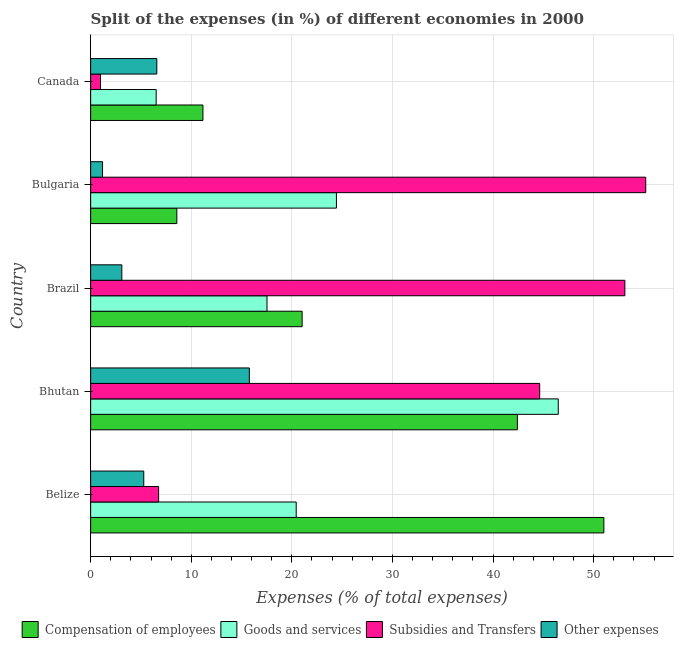How many different coloured bars are there?
Offer a very short reply. 4. Are the number of bars on each tick of the Y-axis equal?
Your response must be concise. Yes. How many bars are there on the 2nd tick from the bottom?
Provide a short and direct response. 4. What is the label of the 2nd group of bars from the top?
Your response must be concise. Bulgaria. What is the percentage of amount spent on subsidies in Canada?
Keep it short and to the point. 0.98. Across all countries, what is the maximum percentage of amount spent on other expenses?
Your response must be concise. 15.77. Across all countries, what is the minimum percentage of amount spent on subsidies?
Offer a very short reply. 0.98. In which country was the percentage of amount spent on compensation of employees maximum?
Your answer should be compact. Belize. In which country was the percentage of amount spent on compensation of employees minimum?
Your answer should be compact. Bulgaria. What is the total percentage of amount spent on compensation of employees in the graph?
Keep it short and to the point. 134.18. What is the difference between the percentage of amount spent on other expenses in Belize and that in Canada?
Give a very brief answer. -1.3. What is the difference between the percentage of amount spent on compensation of employees in Bhutan and the percentage of amount spent on other expenses in Canada?
Your response must be concise. 35.84. What is the average percentage of amount spent on compensation of employees per country?
Offer a very short reply. 26.84. What is the difference between the percentage of amount spent on other expenses and percentage of amount spent on goods and services in Bhutan?
Your response must be concise. -30.71. In how many countries, is the percentage of amount spent on other expenses greater than 14 %?
Ensure brevity in your answer.  1. What is the ratio of the percentage of amount spent on goods and services in Bhutan to that in Brazil?
Provide a short and direct response. 2.65. Is the percentage of amount spent on compensation of employees in Belize less than that in Canada?
Your answer should be very brief. No. What is the difference between the highest and the second highest percentage of amount spent on other expenses?
Your answer should be very brief. 9.2. What is the difference between the highest and the lowest percentage of amount spent on goods and services?
Provide a succinct answer. 39.97. In how many countries, is the percentage of amount spent on subsidies greater than the average percentage of amount spent on subsidies taken over all countries?
Offer a very short reply. 3. What does the 1st bar from the top in Bhutan represents?
Give a very brief answer. Other expenses. What does the 4th bar from the bottom in Bulgaria represents?
Your response must be concise. Other expenses. How many bars are there?
Offer a very short reply. 20. How many countries are there in the graph?
Make the answer very short. 5. What is the difference between two consecutive major ticks on the X-axis?
Your response must be concise. 10. Are the values on the major ticks of X-axis written in scientific E-notation?
Your response must be concise. No. Where does the legend appear in the graph?
Your response must be concise. Bottom center. What is the title of the graph?
Keep it short and to the point. Split of the expenses (in %) of different economies in 2000. Does "HFC gas" appear as one of the legend labels in the graph?
Make the answer very short. No. What is the label or title of the X-axis?
Offer a terse response. Expenses (% of total expenses). What is the Expenses (% of total expenses) in Compensation of employees in Belize?
Offer a very short reply. 51.01. What is the Expenses (% of total expenses) in Goods and services in Belize?
Your answer should be compact. 20.43. What is the Expenses (% of total expenses) of Subsidies and Transfers in Belize?
Give a very brief answer. 6.76. What is the Expenses (% of total expenses) in Other expenses in Belize?
Offer a very short reply. 5.28. What is the Expenses (% of total expenses) of Compensation of employees in Bhutan?
Your answer should be very brief. 42.42. What is the Expenses (% of total expenses) in Goods and services in Bhutan?
Make the answer very short. 46.48. What is the Expenses (% of total expenses) of Subsidies and Transfers in Bhutan?
Your answer should be very brief. 44.63. What is the Expenses (% of total expenses) of Other expenses in Bhutan?
Ensure brevity in your answer.  15.77. What is the Expenses (% of total expenses) in Compensation of employees in Brazil?
Your answer should be compact. 21.02. What is the Expenses (% of total expenses) of Goods and services in Brazil?
Provide a short and direct response. 17.53. What is the Expenses (% of total expenses) in Subsidies and Transfers in Brazil?
Your response must be concise. 53.1. What is the Expenses (% of total expenses) in Other expenses in Brazil?
Your response must be concise. 3.1. What is the Expenses (% of total expenses) in Compensation of employees in Bulgaria?
Keep it short and to the point. 8.57. What is the Expenses (% of total expenses) in Goods and services in Bulgaria?
Provide a short and direct response. 24.43. What is the Expenses (% of total expenses) of Subsidies and Transfers in Bulgaria?
Provide a short and direct response. 55.18. What is the Expenses (% of total expenses) in Other expenses in Bulgaria?
Keep it short and to the point. 1.18. What is the Expenses (% of total expenses) of Compensation of employees in Canada?
Make the answer very short. 11.16. What is the Expenses (% of total expenses) of Goods and services in Canada?
Give a very brief answer. 6.51. What is the Expenses (% of total expenses) of Subsidies and Transfers in Canada?
Your response must be concise. 0.98. What is the Expenses (% of total expenses) in Other expenses in Canada?
Offer a terse response. 6.58. Across all countries, what is the maximum Expenses (% of total expenses) in Compensation of employees?
Provide a short and direct response. 51.01. Across all countries, what is the maximum Expenses (% of total expenses) in Goods and services?
Ensure brevity in your answer.  46.48. Across all countries, what is the maximum Expenses (% of total expenses) of Subsidies and Transfers?
Your answer should be compact. 55.18. Across all countries, what is the maximum Expenses (% of total expenses) in Other expenses?
Offer a terse response. 15.77. Across all countries, what is the minimum Expenses (% of total expenses) in Compensation of employees?
Provide a short and direct response. 8.57. Across all countries, what is the minimum Expenses (% of total expenses) in Goods and services?
Offer a terse response. 6.51. Across all countries, what is the minimum Expenses (% of total expenses) of Subsidies and Transfers?
Offer a terse response. 0.98. Across all countries, what is the minimum Expenses (% of total expenses) in Other expenses?
Offer a terse response. 1.18. What is the total Expenses (% of total expenses) of Compensation of employees in the graph?
Offer a very short reply. 134.18. What is the total Expenses (% of total expenses) in Goods and services in the graph?
Your answer should be very brief. 115.38. What is the total Expenses (% of total expenses) of Subsidies and Transfers in the graph?
Make the answer very short. 160.65. What is the total Expenses (% of total expenses) of Other expenses in the graph?
Provide a short and direct response. 31.91. What is the difference between the Expenses (% of total expenses) in Compensation of employees in Belize and that in Bhutan?
Offer a terse response. 8.6. What is the difference between the Expenses (% of total expenses) in Goods and services in Belize and that in Bhutan?
Ensure brevity in your answer.  -26.05. What is the difference between the Expenses (% of total expenses) in Subsidies and Transfers in Belize and that in Bhutan?
Your answer should be compact. -37.88. What is the difference between the Expenses (% of total expenses) in Other expenses in Belize and that in Bhutan?
Make the answer very short. -10.49. What is the difference between the Expenses (% of total expenses) in Compensation of employees in Belize and that in Brazil?
Give a very brief answer. 29.99. What is the difference between the Expenses (% of total expenses) in Goods and services in Belize and that in Brazil?
Make the answer very short. 2.9. What is the difference between the Expenses (% of total expenses) in Subsidies and Transfers in Belize and that in Brazil?
Your answer should be compact. -46.34. What is the difference between the Expenses (% of total expenses) in Other expenses in Belize and that in Brazil?
Your answer should be compact. 2.18. What is the difference between the Expenses (% of total expenses) in Compensation of employees in Belize and that in Bulgaria?
Provide a short and direct response. 42.45. What is the difference between the Expenses (% of total expenses) of Goods and services in Belize and that in Bulgaria?
Your answer should be compact. -4. What is the difference between the Expenses (% of total expenses) of Subsidies and Transfers in Belize and that in Bulgaria?
Offer a terse response. -48.42. What is the difference between the Expenses (% of total expenses) of Other expenses in Belize and that in Bulgaria?
Ensure brevity in your answer.  4.1. What is the difference between the Expenses (% of total expenses) in Compensation of employees in Belize and that in Canada?
Your answer should be very brief. 39.85. What is the difference between the Expenses (% of total expenses) in Goods and services in Belize and that in Canada?
Your answer should be compact. 13.92. What is the difference between the Expenses (% of total expenses) of Subsidies and Transfers in Belize and that in Canada?
Provide a short and direct response. 5.77. What is the difference between the Expenses (% of total expenses) of Other expenses in Belize and that in Canada?
Provide a short and direct response. -1.3. What is the difference between the Expenses (% of total expenses) of Compensation of employees in Bhutan and that in Brazil?
Keep it short and to the point. 21.4. What is the difference between the Expenses (% of total expenses) of Goods and services in Bhutan and that in Brazil?
Ensure brevity in your answer.  28.95. What is the difference between the Expenses (% of total expenses) in Subsidies and Transfers in Bhutan and that in Brazil?
Your answer should be very brief. -8.47. What is the difference between the Expenses (% of total expenses) in Other expenses in Bhutan and that in Brazil?
Keep it short and to the point. 12.67. What is the difference between the Expenses (% of total expenses) of Compensation of employees in Bhutan and that in Bulgaria?
Provide a succinct answer. 33.85. What is the difference between the Expenses (% of total expenses) in Goods and services in Bhutan and that in Bulgaria?
Offer a very short reply. 22.05. What is the difference between the Expenses (% of total expenses) of Subsidies and Transfers in Bhutan and that in Bulgaria?
Provide a succinct answer. -10.54. What is the difference between the Expenses (% of total expenses) of Other expenses in Bhutan and that in Bulgaria?
Offer a terse response. 14.59. What is the difference between the Expenses (% of total expenses) in Compensation of employees in Bhutan and that in Canada?
Give a very brief answer. 31.26. What is the difference between the Expenses (% of total expenses) of Goods and services in Bhutan and that in Canada?
Offer a very short reply. 39.97. What is the difference between the Expenses (% of total expenses) of Subsidies and Transfers in Bhutan and that in Canada?
Make the answer very short. 43.65. What is the difference between the Expenses (% of total expenses) in Other expenses in Bhutan and that in Canada?
Ensure brevity in your answer.  9.2. What is the difference between the Expenses (% of total expenses) of Compensation of employees in Brazil and that in Bulgaria?
Provide a short and direct response. 12.45. What is the difference between the Expenses (% of total expenses) of Goods and services in Brazil and that in Bulgaria?
Offer a terse response. -6.9. What is the difference between the Expenses (% of total expenses) of Subsidies and Transfers in Brazil and that in Bulgaria?
Make the answer very short. -2.08. What is the difference between the Expenses (% of total expenses) of Other expenses in Brazil and that in Bulgaria?
Ensure brevity in your answer.  1.92. What is the difference between the Expenses (% of total expenses) of Compensation of employees in Brazil and that in Canada?
Ensure brevity in your answer.  9.86. What is the difference between the Expenses (% of total expenses) in Goods and services in Brazil and that in Canada?
Provide a short and direct response. 11.02. What is the difference between the Expenses (% of total expenses) of Subsidies and Transfers in Brazil and that in Canada?
Your response must be concise. 52.12. What is the difference between the Expenses (% of total expenses) in Other expenses in Brazil and that in Canada?
Offer a very short reply. -3.48. What is the difference between the Expenses (% of total expenses) in Compensation of employees in Bulgaria and that in Canada?
Offer a very short reply. -2.6. What is the difference between the Expenses (% of total expenses) of Goods and services in Bulgaria and that in Canada?
Provide a succinct answer. 17.92. What is the difference between the Expenses (% of total expenses) in Subsidies and Transfers in Bulgaria and that in Canada?
Give a very brief answer. 54.19. What is the difference between the Expenses (% of total expenses) in Other expenses in Bulgaria and that in Canada?
Your answer should be compact. -5.39. What is the difference between the Expenses (% of total expenses) of Compensation of employees in Belize and the Expenses (% of total expenses) of Goods and services in Bhutan?
Make the answer very short. 4.53. What is the difference between the Expenses (% of total expenses) of Compensation of employees in Belize and the Expenses (% of total expenses) of Subsidies and Transfers in Bhutan?
Your answer should be very brief. 6.38. What is the difference between the Expenses (% of total expenses) of Compensation of employees in Belize and the Expenses (% of total expenses) of Other expenses in Bhutan?
Make the answer very short. 35.24. What is the difference between the Expenses (% of total expenses) in Goods and services in Belize and the Expenses (% of total expenses) in Subsidies and Transfers in Bhutan?
Keep it short and to the point. -24.2. What is the difference between the Expenses (% of total expenses) of Goods and services in Belize and the Expenses (% of total expenses) of Other expenses in Bhutan?
Give a very brief answer. 4.66. What is the difference between the Expenses (% of total expenses) in Subsidies and Transfers in Belize and the Expenses (% of total expenses) in Other expenses in Bhutan?
Keep it short and to the point. -9.02. What is the difference between the Expenses (% of total expenses) of Compensation of employees in Belize and the Expenses (% of total expenses) of Goods and services in Brazil?
Your answer should be compact. 33.48. What is the difference between the Expenses (% of total expenses) of Compensation of employees in Belize and the Expenses (% of total expenses) of Subsidies and Transfers in Brazil?
Keep it short and to the point. -2.09. What is the difference between the Expenses (% of total expenses) in Compensation of employees in Belize and the Expenses (% of total expenses) in Other expenses in Brazil?
Your answer should be very brief. 47.92. What is the difference between the Expenses (% of total expenses) of Goods and services in Belize and the Expenses (% of total expenses) of Subsidies and Transfers in Brazil?
Provide a short and direct response. -32.67. What is the difference between the Expenses (% of total expenses) of Goods and services in Belize and the Expenses (% of total expenses) of Other expenses in Brazil?
Give a very brief answer. 17.33. What is the difference between the Expenses (% of total expenses) in Subsidies and Transfers in Belize and the Expenses (% of total expenses) in Other expenses in Brazil?
Give a very brief answer. 3.66. What is the difference between the Expenses (% of total expenses) in Compensation of employees in Belize and the Expenses (% of total expenses) in Goods and services in Bulgaria?
Your response must be concise. 26.58. What is the difference between the Expenses (% of total expenses) in Compensation of employees in Belize and the Expenses (% of total expenses) in Subsidies and Transfers in Bulgaria?
Your answer should be compact. -4.16. What is the difference between the Expenses (% of total expenses) in Compensation of employees in Belize and the Expenses (% of total expenses) in Other expenses in Bulgaria?
Provide a succinct answer. 49.83. What is the difference between the Expenses (% of total expenses) in Goods and services in Belize and the Expenses (% of total expenses) in Subsidies and Transfers in Bulgaria?
Offer a very short reply. -34.74. What is the difference between the Expenses (% of total expenses) of Goods and services in Belize and the Expenses (% of total expenses) of Other expenses in Bulgaria?
Offer a terse response. 19.25. What is the difference between the Expenses (% of total expenses) in Subsidies and Transfers in Belize and the Expenses (% of total expenses) in Other expenses in Bulgaria?
Offer a terse response. 5.57. What is the difference between the Expenses (% of total expenses) of Compensation of employees in Belize and the Expenses (% of total expenses) of Goods and services in Canada?
Your answer should be very brief. 44.5. What is the difference between the Expenses (% of total expenses) in Compensation of employees in Belize and the Expenses (% of total expenses) in Subsidies and Transfers in Canada?
Offer a very short reply. 50.03. What is the difference between the Expenses (% of total expenses) in Compensation of employees in Belize and the Expenses (% of total expenses) in Other expenses in Canada?
Ensure brevity in your answer.  44.44. What is the difference between the Expenses (% of total expenses) of Goods and services in Belize and the Expenses (% of total expenses) of Subsidies and Transfers in Canada?
Provide a succinct answer. 19.45. What is the difference between the Expenses (% of total expenses) in Goods and services in Belize and the Expenses (% of total expenses) in Other expenses in Canada?
Give a very brief answer. 13.85. What is the difference between the Expenses (% of total expenses) in Subsidies and Transfers in Belize and the Expenses (% of total expenses) in Other expenses in Canada?
Keep it short and to the point. 0.18. What is the difference between the Expenses (% of total expenses) of Compensation of employees in Bhutan and the Expenses (% of total expenses) of Goods and services in Brazil?
Ensure brevity in your answer.  24.89. What is the difference between the Expenses (% of total expenses) in Compensation of employees in Bhutan and the Expenses (% of total expenses) in Subsidies and Transfers in Brazil?
Provide a succinct answer. -10.68. What is the difference between the Expenses (% of total expenses) of Compensation of employees in Bhutan and the Expenses (% of total expenses) of Other expenses in Brazil?
Your answer should be very brief. 39.32. What is the difference between the Expenses (% of total expenses) in Goods and services in Bhutan and the Expenses (% of total expenses) in Subsidies and Transfers in Brazil?
Your response must be concise. -6.62. What is the difference between the Expenses (% of total expenses) of Goods and services in Bhutan and the Expenses (% of total expenses) of Other expenses in Brazil?
Provide a succinct answer. 43.38. What is the difference between the Expenses (% of total expenses) in Subsidies and Transfers in Bhutan and the Expenses (% of total expenses) in Other expenses in Brazil?
Your answer should be very brief. 41.54. What is the difference between the Expenses (% of total expenses) of Compensation of employees in Bhutan and the Expenses (% of total expenses) of Goods and services in Bulgaria?
Ensure brevity in your answer.  17.99. What is the difference between the Expenses (% of total expenses) of Compensation of employees in Bhutan and the Expenses (% of total expenses) of Subsidies and Transfers in Bulgaria?
Make the answer very short. -12.76. What is the difference between the Expenses (% of total expenses) in Compensation of employees in Bhutan and the Expenses (% of total expenses) in Other expenses in Bulgaria?
Your answer should be compact. 41.23. What is the difference between the Expenses (% of total expenses) in Goods and services in Bhutan and the Expenses (% of total expenses) in Subsidies and Transfers in Bulgaria?
Keep it short and to the point. -8.69. What is the difference between the Expenses (% of total expenses) in Goods and services in Bhutan and the Expenses (% of total expenses) in Other expenses in Bulgaria?
Your answer should be compact. 45.3. What is the difference between the Expenses (% of total expenses) in Subsidies and Transfers in Bhutan and the Expenses (% of total expenses) in Other expenses in Bulgaria?
Your answer should be compact. 43.45. What is the difference between the Expenses (% of total expenses) of Compensation of employees in Bhutan and the Expenses (% of total expenses) of Goods and services in Canada?
Your answer should be very brief. 35.9. What is the difference between the Expenses (% of total expenses) of Compensation of employees in Bhutan and the Expenses (% of total expenses) of Subsidies and Transfers in Canada?
Ensure brevity in your answer.  41.43. What is the difference between the Expenses (% of total expenses) of Compensation of employees in Bhutan and the Expenses (% of total expenses) of Other expenses in Canada?
Keep it short and to the point. 35.84. What is the difference between the Expenses (% of total expenses) in Goods and services in Bhutan and the Expenses (% of total expenses) in Subsidies and Transfers in Canada?
Keep it short and to the point. 45.5. What is the difference between the Expenses (% of total expenses) of Goods and services in Bhutan and the Expenses (% of total expenses) of Other expenses in Canada?
Keep it short and to the point. 39.9. What is the difference between the Expenses (% of total expenses) in Subsidies and Transfers in Bhutan and the Expenses (% of total expenses) in Other expenses in Canada?
Your answer should be very brief. 38.06. What is the difference between the Expenses (% of total expenses) of Compensation of employees in Brazil and the Expenses (% of total expenses) of Goods and services in Bulgaria?
Make the answer very short. -3.41. What is the difference between the Expenses (% of total expenses) in Compensation of employees in Brazil and the Expenses (% of total expenses) in Subsidies and Transfers in Bulgaria?
Provide a short and direct response. -34.16. What is the difference between the Expenses (% of total expenses) in Compensation of employees in Brazil and the Expenses (% of total expenses) in Other expenses in Bulgaria?
Your answer should be very brief. 19.84. What is the difference between the Expenses (% of total expenses) of Goods and services in Brazil and the Expenses (% of total expenses) of Subsidies and Transfers in Bulgaria?
Provide a short and direct response. -37.65. What is the difference between the Expenses (% of total expenses) of Goods and services in Brazil and the Expenses (% of total expenses) of Other expenses in Bulgaria?
Provide a short and direct response. 16.35. What is the difference between the Expenses (% of total expenses) in Subsidies and Transfers in Brazil and the Expenses (% of total expenses) in Other expenses in Bulgaria?
Provide a short and direct response. 51.92. What is the difference between the Expenses (% of total expenses) of Compensation of employees in Brazil and the Expenses (% of total expenses) of Goods and services in Canada?
Provide a succinct answer. 14.51. What is the difference between the Expenses (% of total expenses) in Compensation of employees in Brazil and the Expenses (% of total expenses) in Subsidies and Transfers in Canada?
Provide a succinct answer. 20.04. What is the difference between the Expenses (% of total expenses) in Compensation of employees in Brazil and the Expenses (% of total expenses) in Other expenses in Canada?
Keep it short and to the point. 14.44. What is the difference between the Expenses (% of total expenses) in Goods and services in Brazil and the Expenses (% of total expenses) in Subsidies and Transfers in Canada?
Give a very brief answer. 16.55. What is the difference between the Expenses (% of total expenses) in Goods and services in Brazil and the Expenses (% of total expenses) in Other expenses in Canada?
Ensure brevity in your answer.  10.95. What is the difference between the Expenses (% of total expenses) of Subsidies and Transfers in Brazil and the Expenses (% of total expenses) of Other expenses in Canada?
Provide a short and direct response. 46.52. What is the difference between the Expenses (% of total expenses) of Compensation of employees in Bulgaria and the Expenses (% of total expenses) of Goods and services in Canada?
Give a very brief answer. 2.05. What is the difference between the Expenses (% of total expenses) of Compensation of employees in Bulgaria and the Expenses (% of total expenses) of Subsidies and Transfers in Canada?
Provide a succinct answer. 7.58. What is the difference between the Expenses (% of total expenses) of Compensation of employees in Bulgaria and the Expenses (% of total expenses) of Other expenses in Canada?
Provide a succinct answer. 1.99. What is the difference between the Expenses (% of total expenses) in Goods and services in Bulgaria and the Expenses (% of total expenses) in Subsidies and Transfers in Canada?
Your answer should be very brief. 23.45. What is the difference between the Expenses (% of total expenses) in Goods and services in Bulgaria and the Expenses (% of total expenses) in Other expenses in Canada?
Give a very brief answer. 17.85. What is the difference between the Expenses (% of total expenses) of Subsidies and Transfers in Bulgaria and the Expenses (% of total expenses) of Other expenses in Canada?
Your response must be concise. 48.6. What is the average Expenses (% of total expenses) in Compensation of employees per country?
Your answer should be very brief. 26.84. What is the average Expenses (% of total expenses) of Goods and services per country?
Your answer should be compact. 23.08. What is the average Expenses (% of total expenses) in Subsidies and Transfers per country?
Give a very brief answer. 32.13. What is the average Expenses (% of total expenses) in Other expenses per country?
Your response must be concise. 6.38. What is the difference between the Expenses (% of total expenses) in Compensation of employees and Expenses (% of total expenses) in Goods and services in Belize?
Provide a short and direct response. 30.58. What is the difference between the Expenses (% of total expenses) of Compensation of employees and Expenses (% of total expenses) of Subsidies and Transfers in Belize?
Offer a very short reply. 44.26. What is the difference between the Expenses (% of total expenses) in Compensation of employees and Expenses (% of total expenses) in Other expenses in Belize?
Give a very brief answer. 45.73. What is the difference between the Expenses (% of total expenses) of Goods and services and Expenses (% of total expenses) of Subsidies and Transfers in Belize?
Provide a short and direct response. 13.68. What is the difference between the Expenses (% of total expenses) in Goods and services and Expenses (% of total expenses) in Other expenses in Belize?
Make the answer very short. 15.15. What is the difference between the Expenses (% of total expenses) of Subsidies and Transfers and Expenses (% of total expenses) of Other expenses in Belize?
Provide a short and direct response. 1.48. What is the difference between the Expenses (% of total expenses) in Compensation of employees and Expenses (% of total expenses) in Goods and services in Bhutan?
Offer a terse response. -4.06. What is the difference between the Expenses (% of total expenses) in Compensation of employees and Expenses (% of total expenses) in Subsidies and Transfers in Bhutan?
Keep it short and to the point. -2.22. What is the difference between the Expenses (% of total expenses) in Compensation of employees and Expenses (% of total expenses) in Other expenses in Bhutan?
Your response must be concise. 26.64. What is the difference between the Expenses (% of total expenses) of Goods and services and Expenses (% of total expenses) of Subsidies and Transfers in Bhutan?
Ensure brevity in your answer.  1.85. What is the difference between the Expenses (% of total expenses) in Goods and services and Expenses (% of total expenses) in Other expenses in Bhutan?
Your answer should be compact. 30.71. What is the difference between the Expenses (% of total expenses) in Subsidies and Transfers and Expenses (% of total expenses) in Other expenses in Bhutan?
Provide a short and direct response. 28.86. What is the difference between the Expenses (% of total expenses) of Compensation of employees and Expenses (% of total expenses) of Goods and services in Brazil?
Offer a terse response. 3.49. What is the difference between the Expenses (% of total expenses) in Compensation of employees and Expenses (% of total expenses) in Subsidies and Transfers in Brazil?
Make the answer very short. -32.08. What is the difference between the Expenses (% of total expenses) of Compensation of employees and Expenses (% of total expenses) of Other expenses in Brazil?
Ensure brevity in your answer.  17.92. What is the difference between the Expenses (% of total expenses) of Goods and services and Expenses (% of total expenses) of Subsidies and Transfers in Brazil?
Keep it short and to the point. -35.57. What is the difference between the Expenses (% of total expenses) of Goods and services and Expenses (% of total expenses) of Other expenses in Brazil?
Give a very brief answer. 14.43. What is the difference between the Expenses (% of total expenses) of Subsidies and Transfers and Expenses (% of total expenses) of Other expenses in Brazil?
Your answer should be compact. 50. What is the difference between the Expenses (% of total expenses) in Compensation of employees and Expenses (% of total expenses) in Goods and services in Bulgaria?
Provide a short and direct response. -15.86. What is the difference between the Expenses (% of total expenses) of Compensation of employees and Expenses (% of total expenses) of Subsidies and Transfers in Bulgaria?
Offer a terse response. -46.61. What is the difference between the Expenses (% of total expenses) in Compensation of employees and Expenses (% of total expenses) in Other expenses in Bulgaria?
Offer a terse response. 7.38. What is the difference between the Expenses (% of total expenses) in Goods and services and Expenses (% of total expenses) in Subsidies and Transfers in Bulgaria?
Your answer should be very brief. -30.75. What is the difference between the Expenses (% of total expenses) of Goods and services and Expenses (% of total expenses) of Other expenses in Bulgaria?
Ensure brevity in your answer.  23.25. What is the difference between the Expenses (% of total expenses) of Subsidies and Transfers and Expenses (% of total expenses) of Other expenses in Bulgaria?
Offer a very short reply. 53.99. What is the difference between the Expenses (% of total expenses) of Compensation of employees and Expenses (% of total expenses) of Goods and services in Canada?
Your answer should be very brief. 4.65. What is the difference between the Expenses (% of total expenses) of Compensation of employees and Expenses (% of total expenses) of Subsidies and Transfers in Canada?
Your answer should be compact. 10.18. What is the difference between the Expenses (% of total expenses) in Compensation of employees and Expenses (% of total expenses) in Other expenses in Canada?
Provide a succinct answer. 4.58. What is the difference between the Expenses (% of total expenses) in Goods and services and Expenses (% of total expenses) in Subsidies and Transfers in Canada?
Keep it short and to the point. 5.53. What is the difference between the Expenses (% of total expenses) of Goods and services and Expenses (% of total expenses) of Other expenses in Canada?
Provide a short and direct response. -0.06. What is the difference between the Expenses (% of total expenses) in Subsidies and Transfers and Expenses (% of total expenses) in Other expenses in Canada?
Offer a very short reply. -5.59. What is the ratio of the Expenses (% of total expenses) of Compensation of employees in Belize to that in Bhutan?
Ensure brevity in your answer.  1.2. What is the ratio of the Expenses (% of total expenses) of Goods and services in Belize to that in Bhutan?
Provide a short and direct response. 0.44. What is the ratio of the Expenses (% of total expenses) of Subsidies and Transfers in Belize to that in Bhutan?
Provide a succinct answer. 0.15. What is the ratio of the Expenses (% of total expenses) of Other expenses in Belize to that in Bhutan?
Your answer should be compact. 0.33. What is the ratio of the Expenses (% of total expenses) in Compensation of employees in Belize to that in Brazil?
Provide a succinct answer. 2.43. What is the ratio of the Expenses (% of total expenses) in Goods and services in Belize to that in Brazil?
Your answer should be compact. 1.17. What is the ratio of the Expenses (% of total expenses) of Subsidies and Transfers in Belize to that in Brazil?
Keep it short and to the point. 0.13. What is the ratio of the Expenses (% of total expenses) of Other expenses in Belize to that in Brazil?
Make the answer very short. 1.7. What is the ratio of the Expenses (% of total expenses) of Compensation of employees in Belize to that in Bulgaria?
Provide a short and direct response. 5.96. What is the ratio of the Expenses (% of total expenses) of Goods and services in Belize to that in Bulgaria?
Give a very brief answer. 0.84. What is the ratio of the Expenses (% of total expenses) of Subsidies and Transfers in Belize to that in Bulgaria?
Provide a short and direct response. 0.12. What is the ratio of the Expenses (% of total expenses) in Other expenses in Belize to that in Bulgaria?
Keep it short and to the point. 4.47. What is the ratio of the Expenses (% of total expenses) of Compensation of employees in Belize to that in Canada?
Make the answer very short. 4.57. What is the ratio of the Expenses (% of total expenses) of Goods and services in Belize to that in Canada?
Provide a succinct answer. 3.14. What is the ratio of the Expenses (% of total expenses) in Subsidies and Transfers in Belize to that in Canada?
Your answer should be very brief. 6.88. What is the ratio of the Expenses (% of total expenses) in Other expenses in Belize to that in Canada?
Keep it short and to the point. 0.8. What is the ratio of the Expenses (% of total expenses) of Compensation of employees in Bhutan to that in Brazil?
Ensure brevity in your answer.  2.02. What is the ratio of the Expenses (% of total expenses) in Goods and services in Bhutan to that in Brazil?
Offer a terse response. 2.65. What is the ratio of the Expenses (% of total expenses) in Subsidies and Transfers in Bhutan to that in Brazil?
Give a very brief answer. 0.84. What is the ratio of the Expenses (% of total expenses) in Other expenses in Bhutan to that in Brazil?
Offer a terse response. 5.09. What is the ratio of the Expenses (% of total expenses) in Compensation of employees in Bhutan to that in Bulgaria?
Give a very brief answer. 4.95. What is the ratio of the Expenses (% of total expenses) of Goods and services in Bhutan to that in Bulgaria?
Give a very brief answer. 1.9. What is the ratio of the Expenses (% of total expenses) in Subsidies and Transfers in Bhutan to that in Bulgaria?
Your response must be concise. 0.81. What is the ratio of the Expenses (% of total expenses) in Other expenses in Bhutan to that in Bulgaria?
Offer a very short reply. 13.34. What is the ratio of the Expenses (% of total expenses) of Compensation of employees in Bhutan to that in Canada?
Your answer should be very brief. 3.8. What is the ratio of the Expenses (% of total expenses) in Goods and services in Bhutan to that in Canada?
Offer a terse response. 7.14. What is the ratio of the Expenses (% of total expenses) of Subsidies and Transfers in Bhutan to that in Canada?
Your response must be concise. 45.45. What is the ratio of the Expenses (% of total expenses) of Other expenses in Bhutan to that in Canada?
Your response must be concise. 2.4. What is the ratio of the Expenses (% of total expenses) in Compensation of employees in Brazil to that in Bulgaria?
Make the answer very short. 2.45. What is the ratio of the Expenses (% of total expenses) in Goods and services in Brazil to that in Bulgaria?
Make the answer very short. 0.72. What is the ratio of the Expenses (% of total expenses) of Subsidies and Transfers in Brazil to that in Bulgaria?
Make the answer very short. 0.96. What is the ratio of the Expenses (% of total expenses) in Other expenses in Brazil to that in Bulgaria?
Make the answer very short. 2.62. What is the ratio of the Expenses (% of total expenses) in Compensation of employees in Brazil to that in Canada?
Your answer should be very brief. 1.88. What is the ratio of the Expenses (% of total expenses) in Goods and services in Brazil to that in Canada?
Provide a short and direct response. 2.69. What is the ratio of the Expenses (% of total expenses) of Subsidies and Transfers in Brazil to that in Canada?
Keep it short and to the point. 54.07. What is the ratio of the Expenses (% of total expenses) of Other expenses in Brazil to that in Canada?
Give a very brief answer. 0.47. What is the ratio of the Expenses (% of total expenses) in Compensation of employees in Bulgaria to that in Canada?
Offer a very short reply. 0.77. What is the ratio of the Expenses (% of total expenses) of Goods and services in Bulgaria to that in Canada?
Offer a terse response. 3.75. What is the ratio of the Expenses (% of total expenses) of Subsidies and Transfers in Bulgaria to that in Canada?
Your answer should be compact. 56.18. What is the ratio of the Expenses (% of total expenses) in Other expenses in Bulgaria to that in Canada?
Make the answer very short. 0.18. What is the difference between the highest and the second highest Expenses (% of total expenses) of Compensation of employees?
Provide a short and direct response. 8.6. What is the difference between the highest and the second highest Expenses (% of total expenses) in Goods and services?
Offer a very short reply. 22.05. What is the difference between the highest and the second highest Expenses (% of total expenses) of Subsidies and Transfers?
Give a very brief answer. 2.08. What is the difference between the highest and the second highest Expenses (% of total expenses) in Other expenses?
Offer a very short reply. 9.2. What is the difference between the highest and the lowest Expenses (% of total expenses) in Compensation of employees?
Provide a short and direct response. 42.45. What is the difference between the highest and the lowest Expenses (% of total expenses) of Goods and services?
Give a very brief answer. 39.97. What is the difference between the highest and the lowest Expenses (% of total expenses) in Subsidies and Transfers?
Ensure brevity in your answer.  54.19. What is the difference between the highest and the lowest Expenses (% of total expenses) in Other expenses?
Provide a short and direct response. 14.59. 